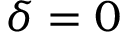Convert formula to latex. <formula><loc_0><loc_0><loc_500><loc_500>\delta = 0</formula> 